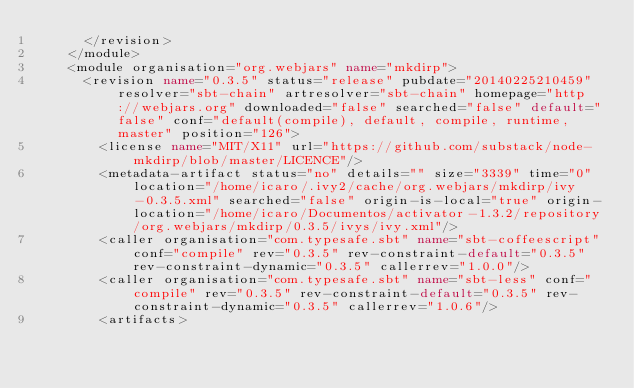<code> <loc_0><loc_0><loc_500><loc_500><_XML_>			</revision>
		</module>
		<module organisation="org.webjars" name="mkdirp">
			<revision name="0.3.5" status="release" pubdate="20140225210459" resolver="sbt-chain" artresolver="sbt-chain" homepage="http://webjars.org" downloaded="false" searched="false" default="false" conf="default(compile), default, compile, runtime, master" position="126">
				<license name="MIT/X11" url="https://github.com/substack/node-mkdirp/blob/master/LICENCE"/>
				<metadata-artifact status="no" details="" size="3339" time="0" location="/home/icaro/.ivy2/cache/org.webjars/mkdirp/ivy-0.3.5.xml" searched="false" origin-is-local="true" origin-location="/home/icaro/Documentos/activator-1.3.2/repository/org.webjars/mkdirp/0.3.5/ivys/ivy.xml"/>
				<caller organisation="com.typesafe.sbt" name="sbt-coffeescript" conf="compile" rev="0.3.5" rev-constraint-default="0.3.5" rev-constraint-dynamic="0.3.5" callerrev="1.0.0"/>
				<caller organisation="com.typesafe.sbt" name="sbt-less" conf="compile" rev="0.3.5" rev-constraint-default="0.3.5" rev-constraint-dynamic="0.3.5" callerrev="1.0.6"/>
				<artifacts></code> 